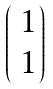<formula> <loc_0><loc_0><loc_500><loc_500>\begin{pmatrix} \ 1 \\ \ 1 \end{pmatrix}</formula> 